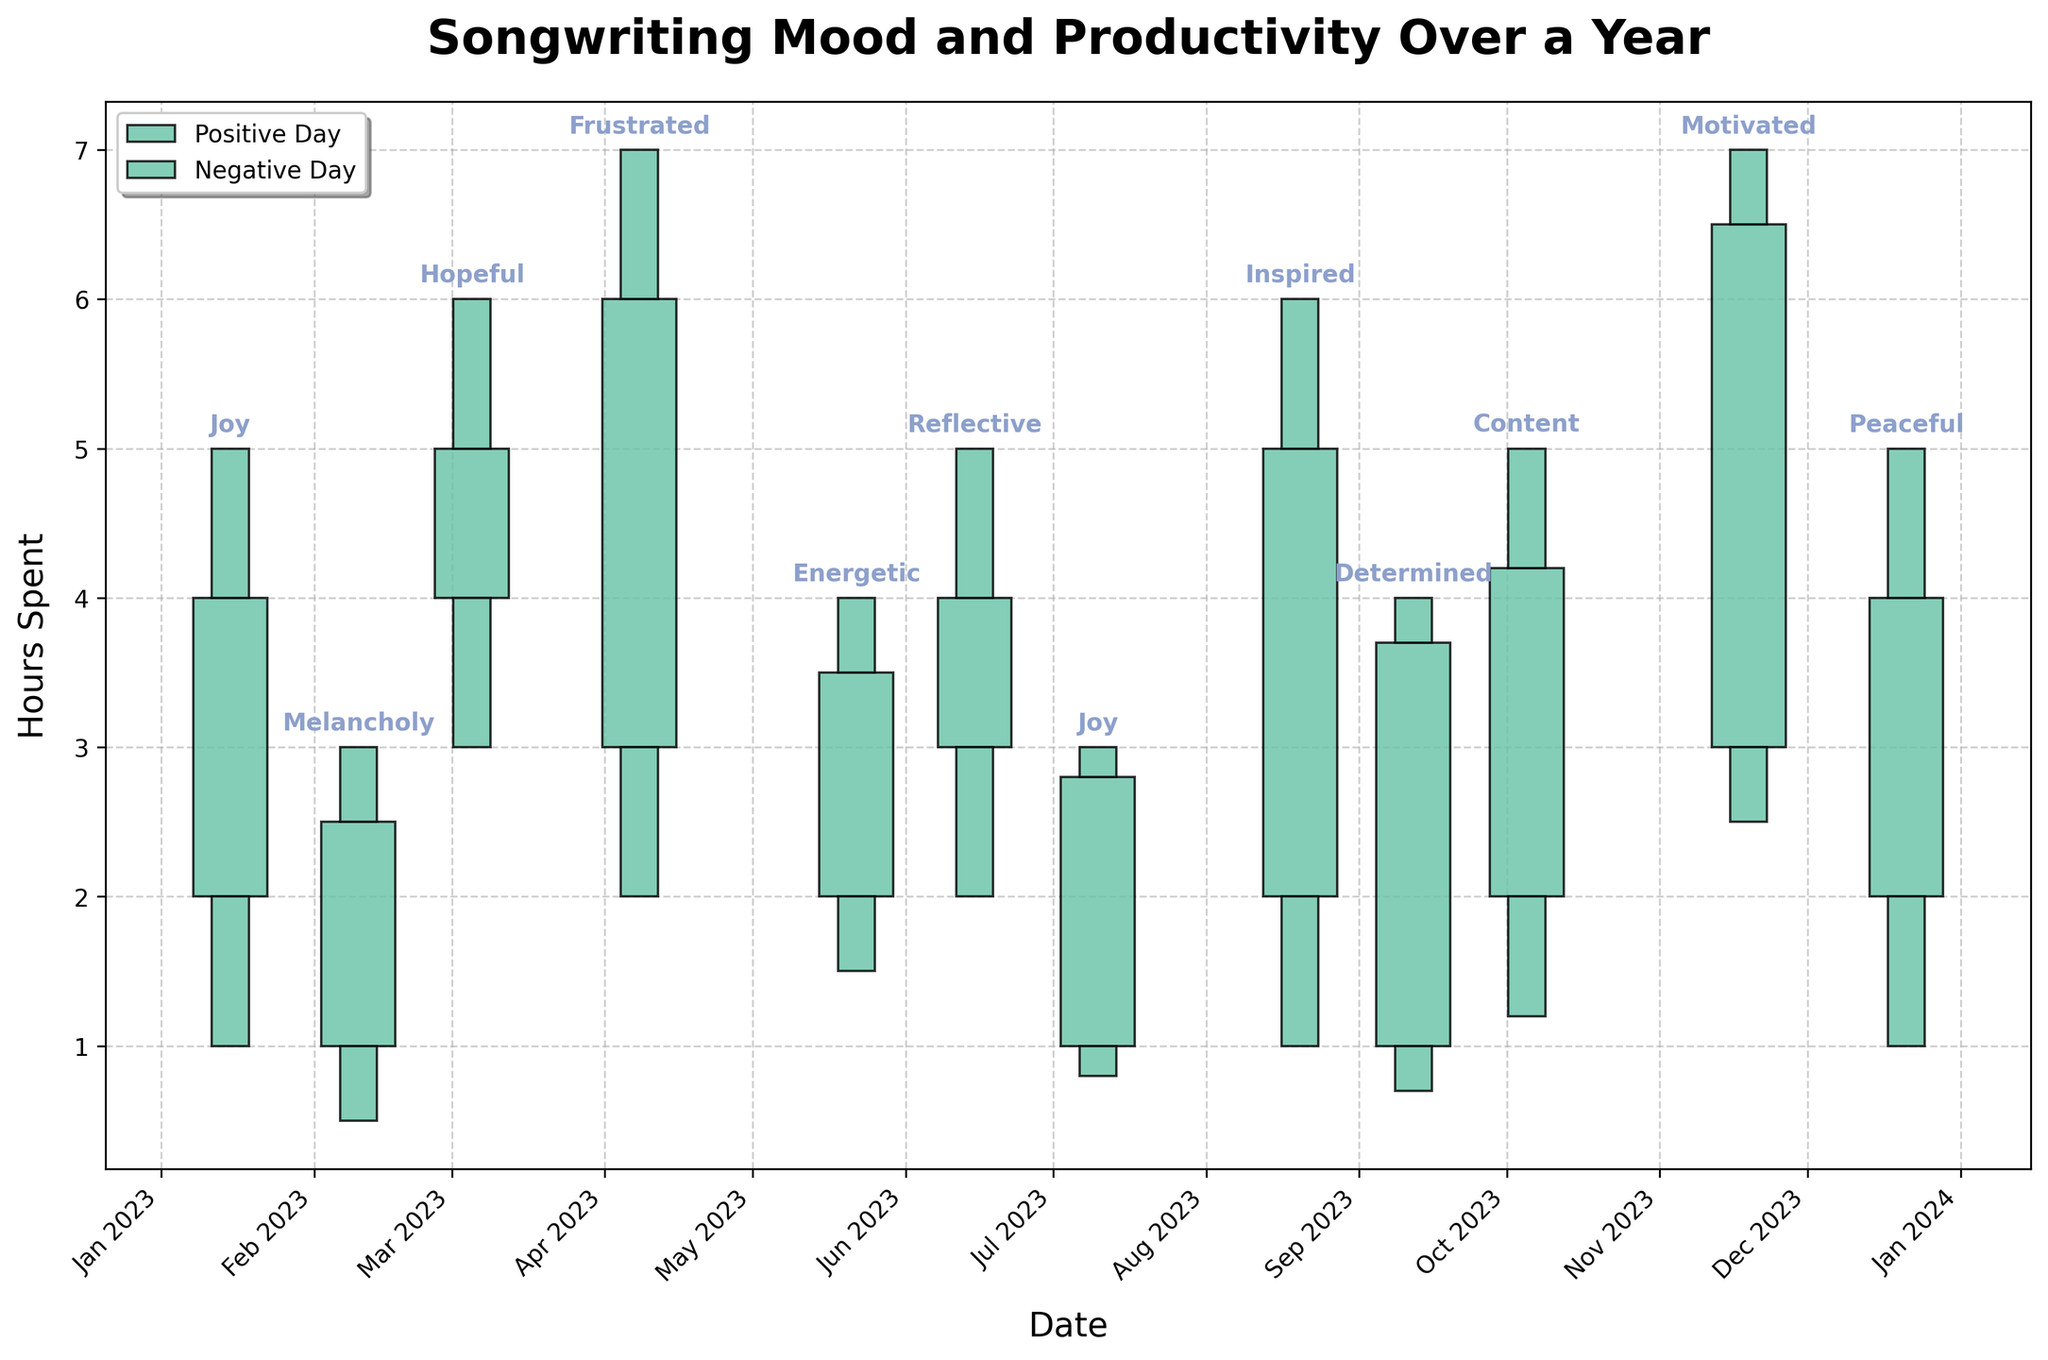How many total data points are represented in the plot? The plot has one data point per month over the span of one year. Since there are 12 months in a year, there are 12 data points.
Answer: 12 How many days show a positive mood where the closing value is greater than the opening value? Identify the green bars in the plot, which signify positive days (Close >= Open). Count the green bars to get the answer.
Answer: 8 Which month had the highest high value, and what was the corresponding mood? Look for the tallest vertical line (highest high value) on the plot, identify the month, and read the mood label attached to it. The highest high is in April with a high of 7, labeled as "Frustrated".
Answer: April; Frustrated During which month did the lowest low value occur, and what was the mood associated with that month? Identify the shortest vertical line (lowest low value) on the plot. It occurred in February, with the mood labeled as "Melancholy".
Answer: February; Melancholy Compare January and December: Which month had a higher closing value? Find the closing values for January and December by checking the end points of the vertical lines for these months. January’s closing value is 4, December’s closing value is also 4.
Answer: Equal What is the average high value across all months? Add up all the high values provided in the dataset (5, 3, 6, 7, 4, 5, 3, 6, 4, 5, 7, 5) and divide by the number of months, which is 12. The sum is 60, and 60 divided by 12 is 5.
Answer: 5 How many days showed a closing value less than the opening value? Identify the red bars in the plot, signifying negative days (Close < Open). Count the red bars to get the answer.
Answer: 4 Which mood appears to correlate with the most productive months (highest closing values)? Look for the months with the highest closing values and check the mood labels. The highest closing values are 6 in April (Frustrated) and 6.5 in November (Motivated).
Answer: Frustrated, Motivated 